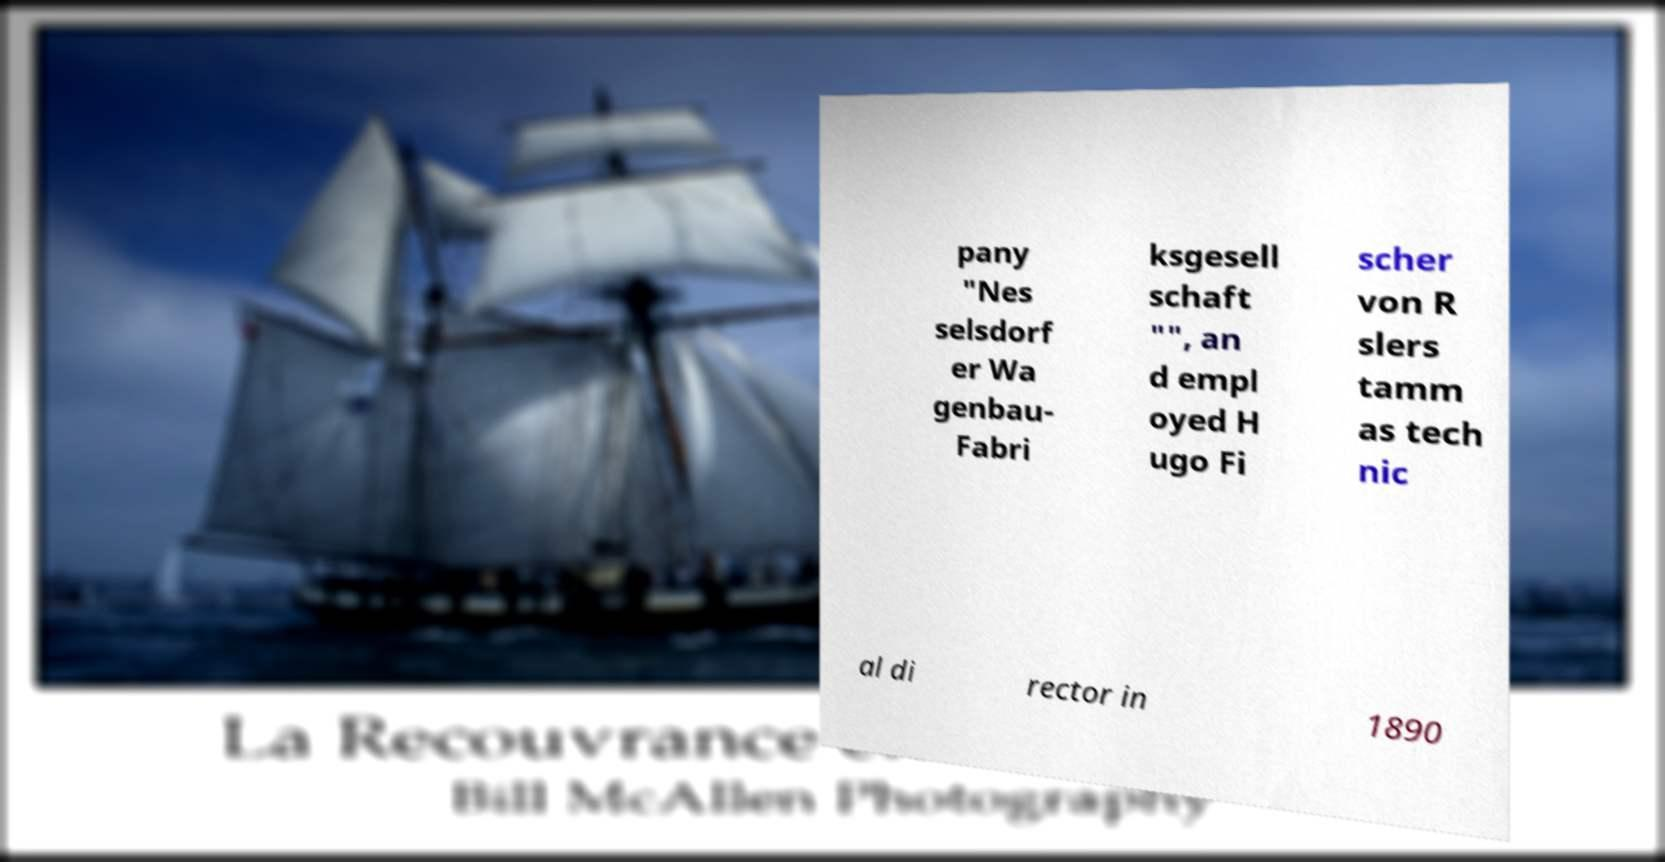Please read and relay the text visible in this image. What does it say? pany "Nes selsdorf er Wa genbau- Fabri ksgesell schaft "", an d empl oyed H ugo Fi scher von R slers tamm as tech nic al di rector in 1890 